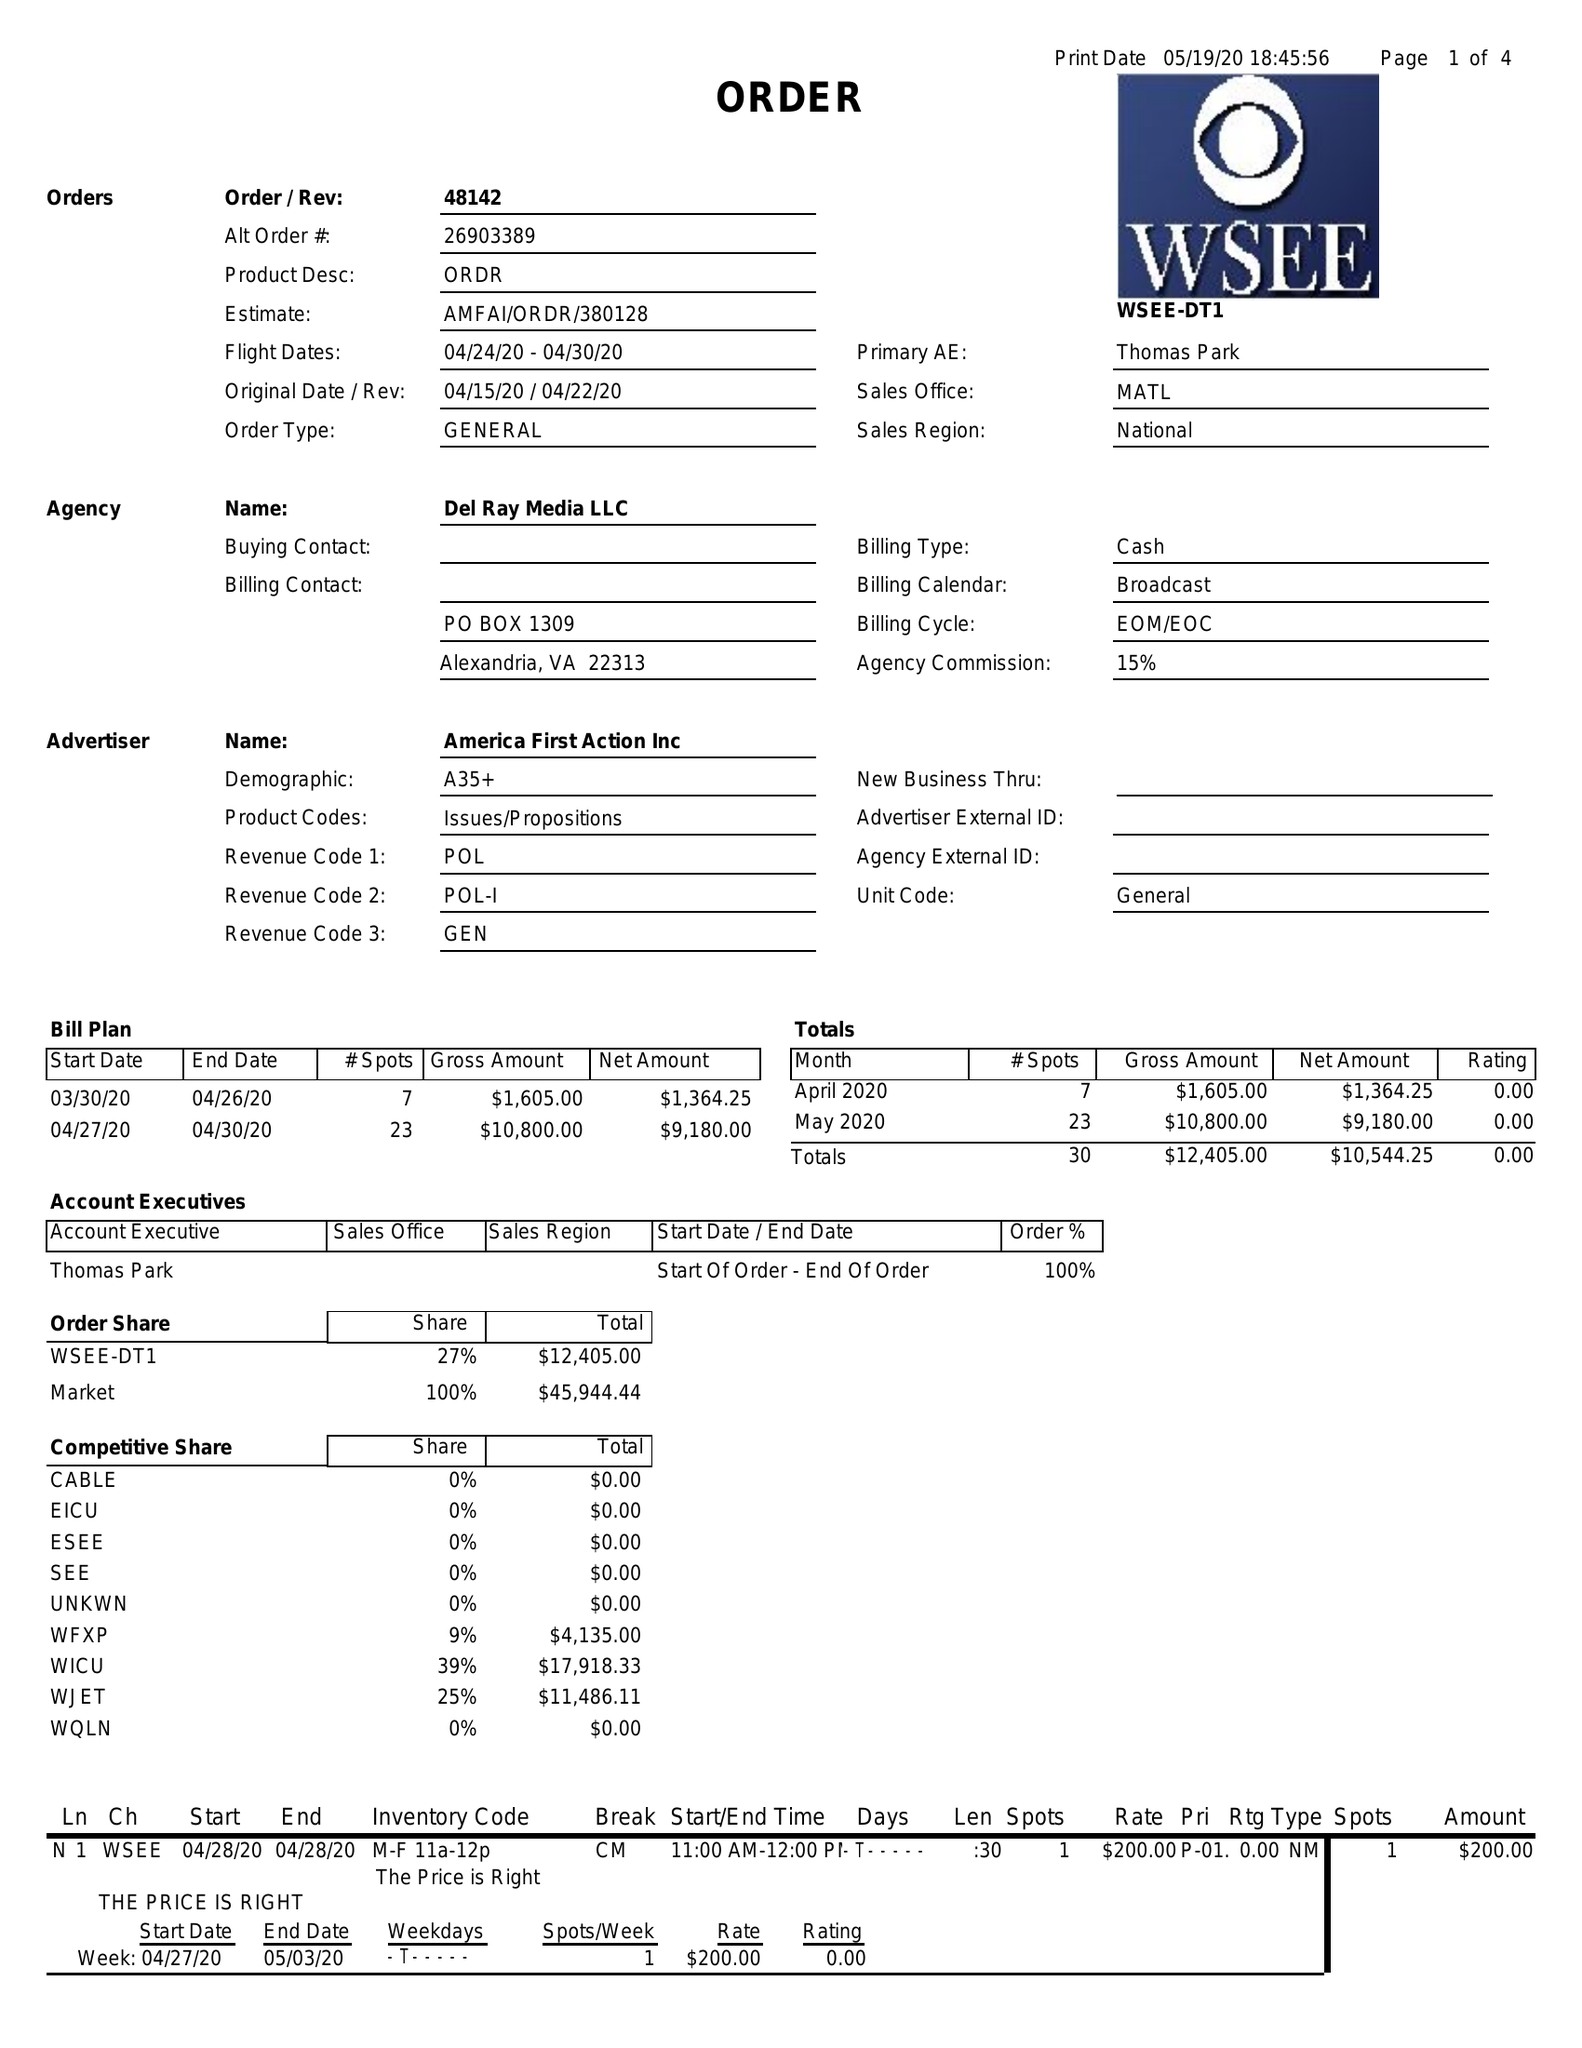What is the value for the flight_from?
Answer the question using a single word or phrase. 04/24/20 